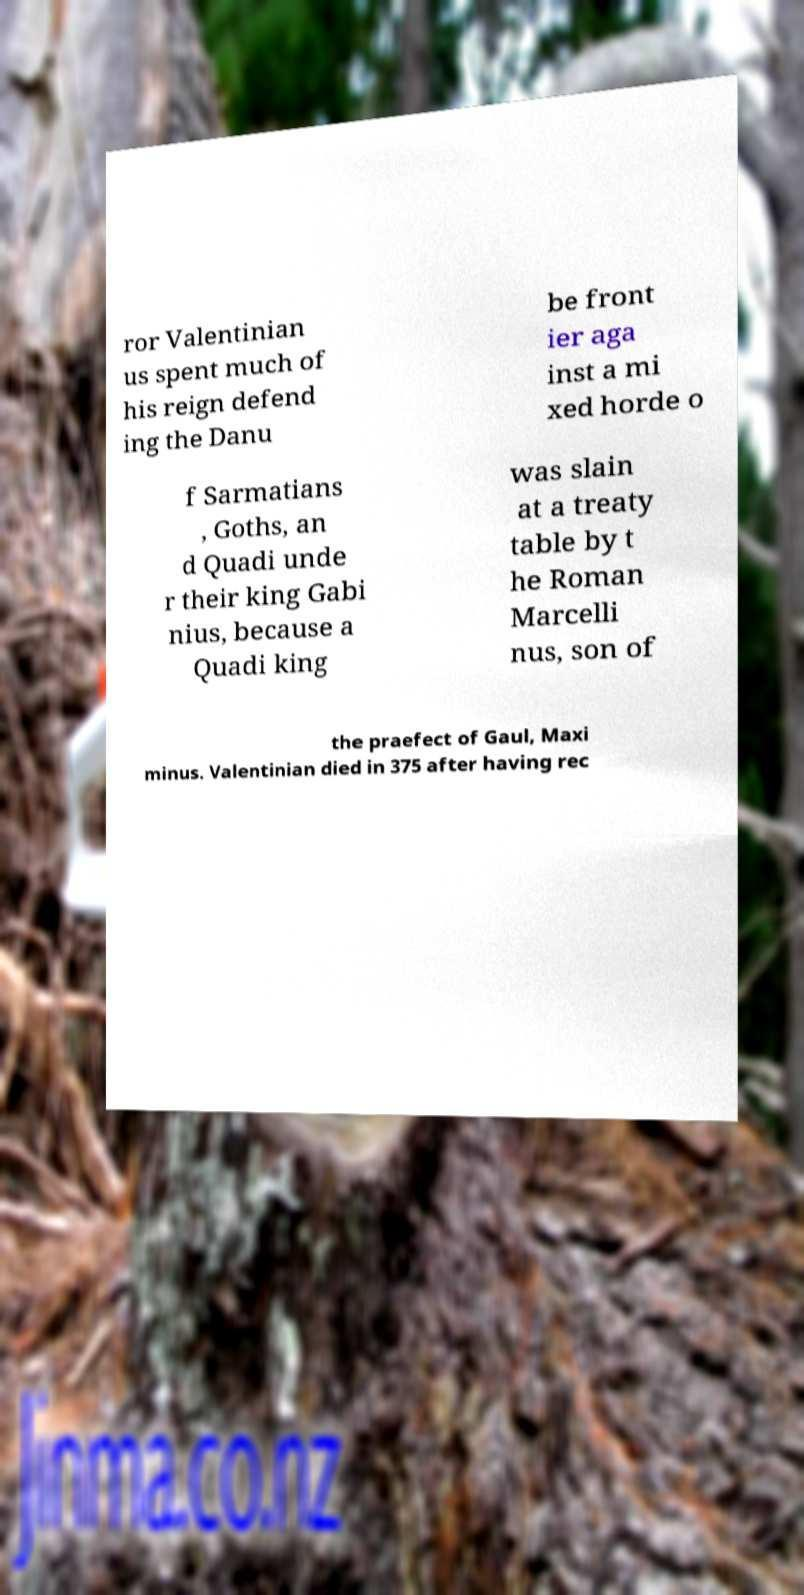Please identify and transcribe the text found in this image. ror Valentinian us spent much of his reign defend ing the Danu be front ier aga inst a mi xed horde o f Sarmatians , Goths, an d Quadi unde r their king Gabi nius, because a Quadi king was slain at a treaty table by t he Roman Marcelli nus, son of the praefect of Gaul, Maxi minus. Valentinian died in 375 after having rec 